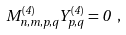<formula> <loc_0><loc_0><loc_500><loc_500>M ^ { ( 4 ) } _ { n , m , p , q } Y ^ { ( 4 ) } _ { p , q } = 0 \ ,</formula> 